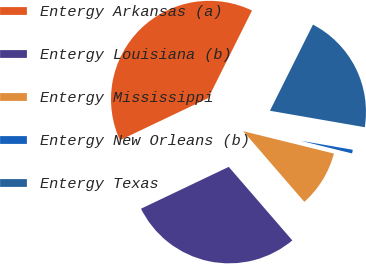Convert chart. <chart><loc_0><loc_0><loc_500><loc_500><pie_chart><fcel>Entergy Arkansas (a)<fcel>Entergy Louisiana (b)<fcel>Entergy Mississippi<fcel>Entergy New Orleans (b)<fcel>Entergy Texas<nl><fcel>39.46%<fcel>29.26%<fcel>9.8%<fcel>1.12%<fcel>20.36%<nl></chart> 